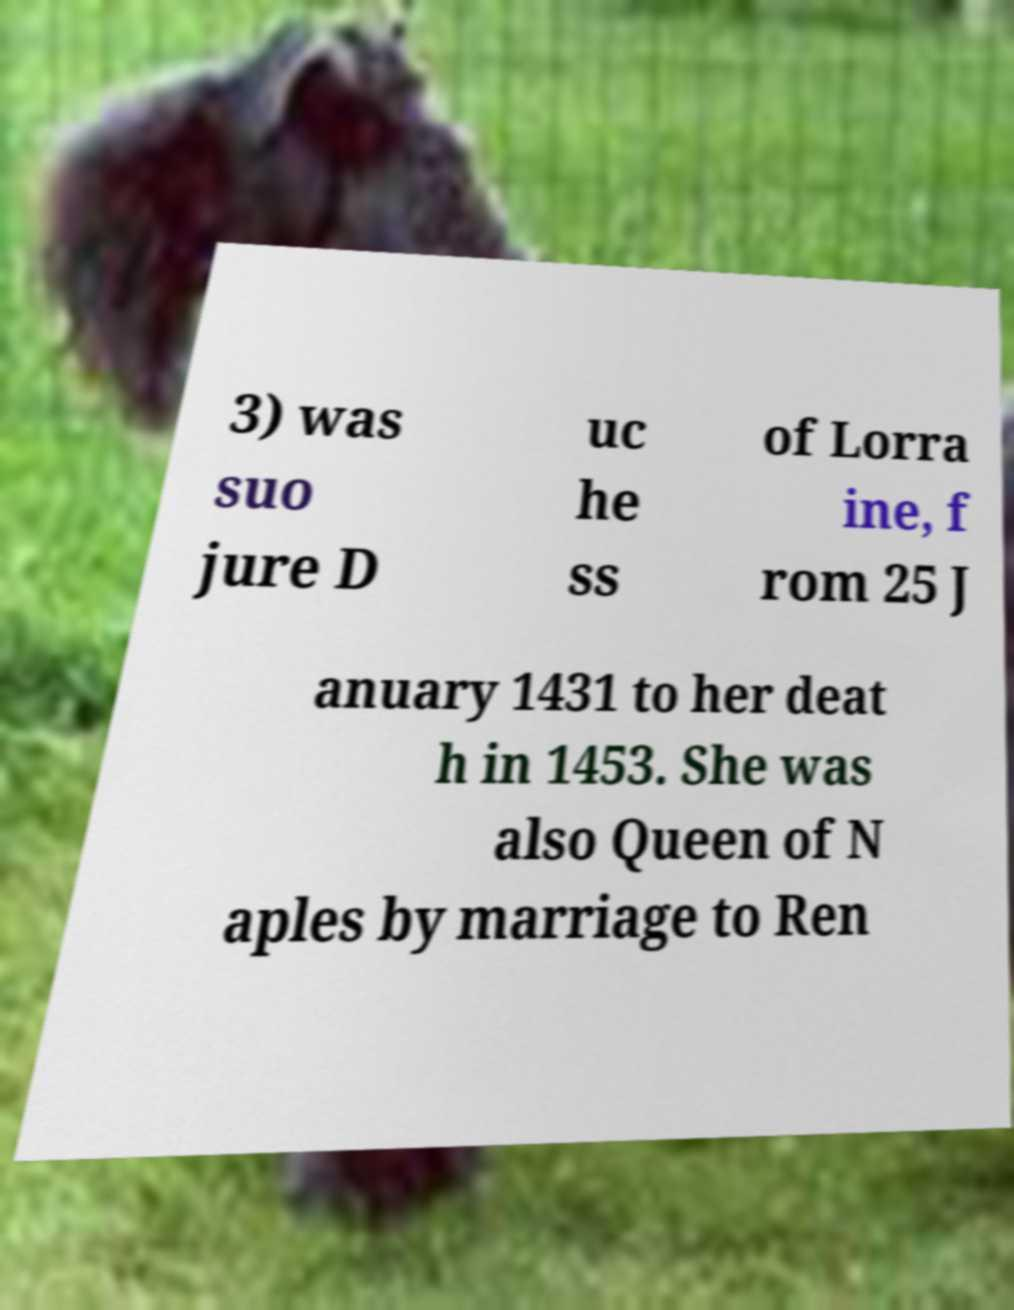Can you accurately transcribe the text from the provided image for me? 3) was suo jure D uc he ss of Lorra ine, f rom 25 J anuary 1431 to her deat h in 1453. She was also Queen of N aples by marriage to Ren 